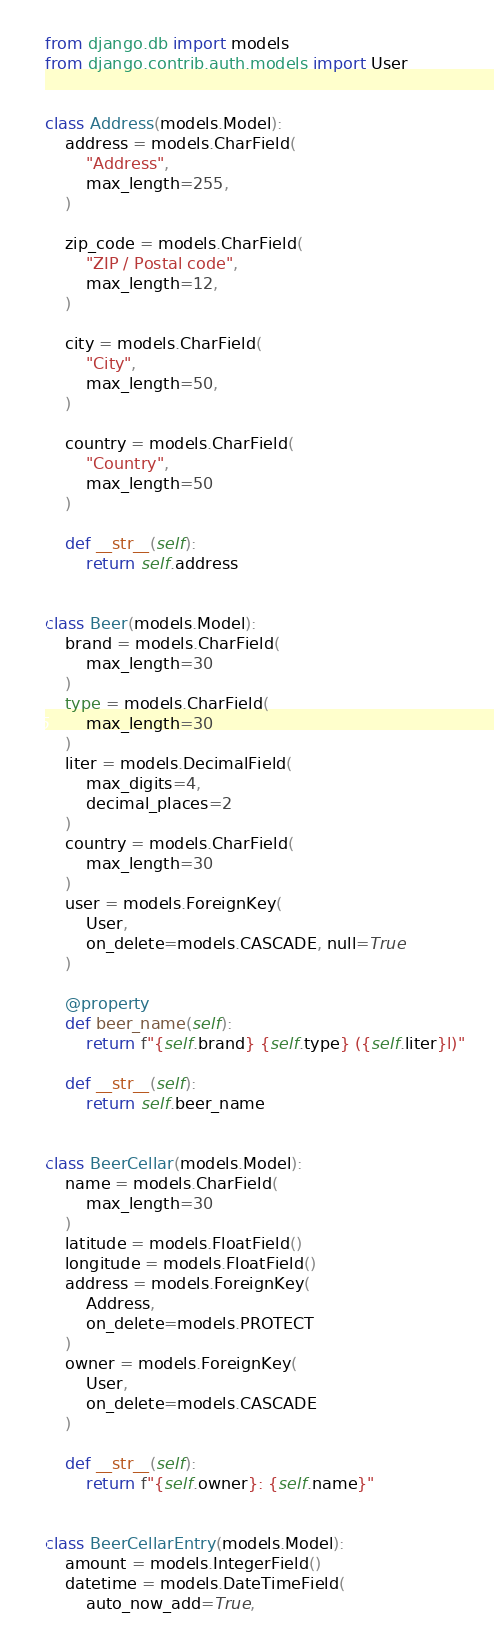<code> <loc_0><loc_0><loc_500><loc_500><_Python_>from django.db import models
from django.contrib.auth.models import User


class Address(models.Model):
    address = models.CharField(
        "Address",
        max_length=255,
    )

    zip_code = models.CharField(
        "ZIP / Postal code",
        max_length=12,
    )

    city = models.CharField(
        "City",
        max_length=50,
    )

    country = models.CharField(
        "Country",
        max_length=50
    )

    def __str__(self):
        return self.address


class Beer(models.Model):
    brand = models.CharField(
        max_length=30
    )
    type = models.CharField(
        max_length=30
    )
    liter = models.DecimalField(
        max_digits=4,
        decimal_places=2
    )
    country = models.CharField(
        max_length=30
    )
    user = models.ForeignKey(
        User,
        on_delete=models.CASCADE, null=True
    )

    @property
    def beer_name(self):
        return f"{self.brand} {self.type} ({self.liter}l)"

    def __str__(self):
        return self.beer_name


class BeerCellar(models.Model):
    name = models.CharField(
        max_length=30
    )
    latitude = models.FloatField()
    longitude = models.FloatField()
    address = models.ForeignKey(
        Address,
        on_delete=models.PROTECT
    )
    owner = models.ForeignKey(
        User,
        on_delete=models.CASCADE
    )

    def __str__(self):
        return f"{self.owner}: {self.name}"


class BeerCellarEntry(models.Model):
    amount = models.IntegerField()
    datetime = models.DateTimeField(
        auto_now_add=True,</code> 